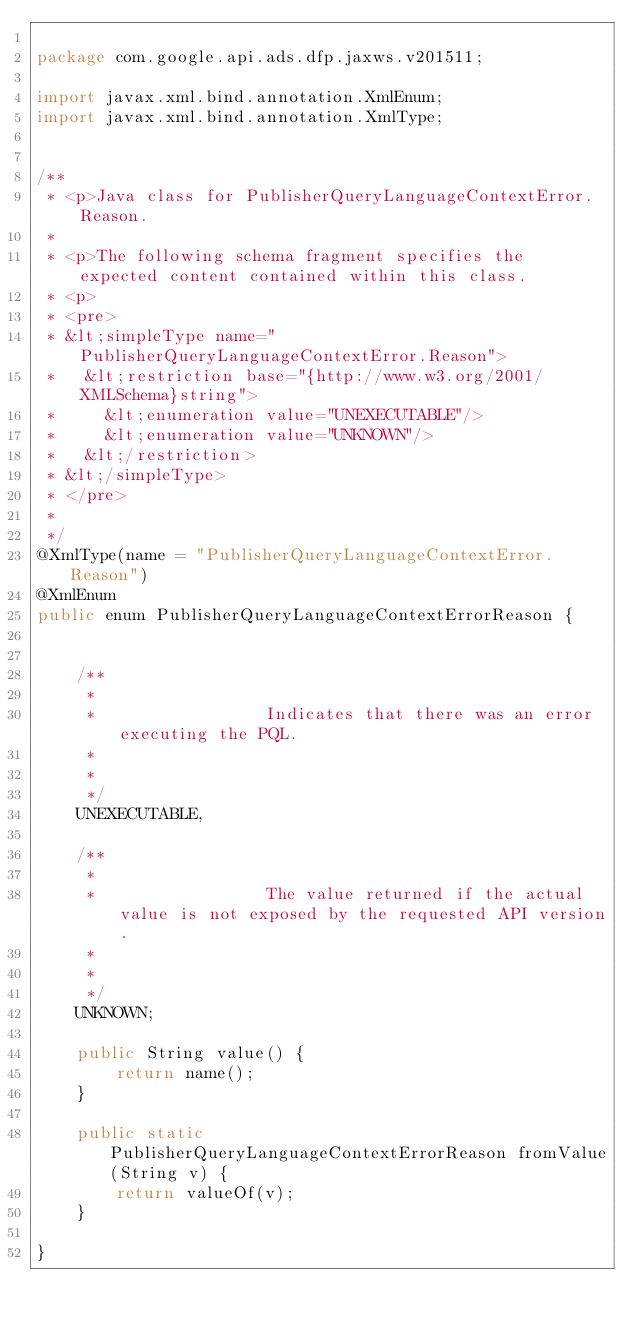Convert code to text. <code><loc_0><loc_0><loc_500><loc_500><_Java_>
package com.google.api.ads.dfp.jaxws.v201511;

import javax.xml.bind.annotation.XmlEnum;
import javax.xml.bind.annotation.XmlType;


/**
 * <p>Java class for PublisherQueryLanguageContextError.Reason.
 * 
 * <p>The following schema fragment specifies the expected content contained within this class.
 * <p>
 * <pre>
 * &lt;simpleType name="PublisherQueryLanguageContextError.Reason">
 *   &lt;restriction base="{http://www.w3.org/2001/XMLSchema}string">
 *     &lt;enumeration value="UNEXECUTABLE"/>
 *     &lt;enumeration value="UNKNOWN"/>
 *   &lt;/restriction>
 * &lt;/simpleType>
 * </pre>
 * 
 */
@XmlType(name = "PublisherQueryLanguageContextError.Reason")
@XmlEnum
public enum PublisherQueryLanguageContextErrorReason {


    /**
     * 
     *                 Indicates that there was an error executing the PQL.
     *               
     * 
     */
    UNEXECUTABLE,

    /**
     * 
     *                 The value returned if the actual value is not exposed by the requested API version.
     *               
     * 
     */
    UNKNOWN;

    public String value() {
        return name();
    }

    public static PublisherQueryLanguageContextErrorReason fromValue(String v) {
        return valueOf(v);
    }

}
</code> 